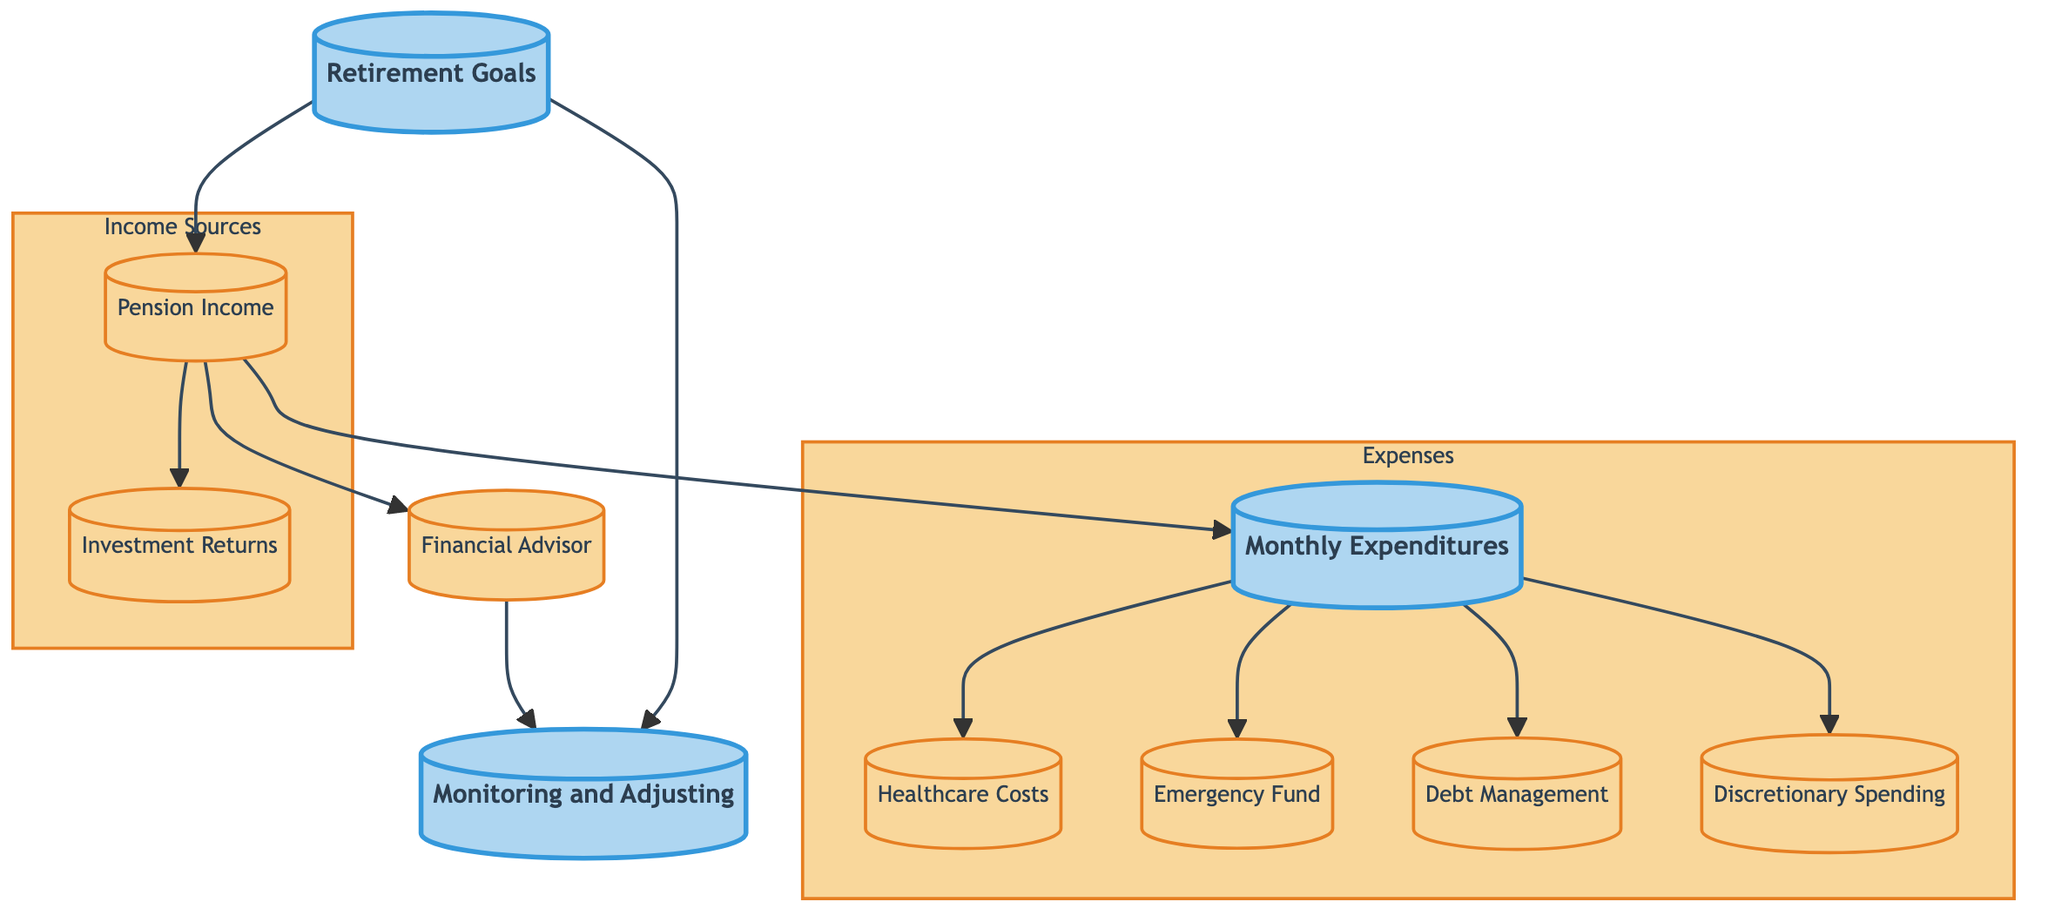What is the first step after defining retirement goals? The diagram indicates that after defining retirement goals, the next step is to calculate pension income, as shown by the arrow leading from "Retirement Goals" to "Pension Income."
Answer: calculate pension income How many key categories are presented in the flowchart? The flowchart categorizes the information into two main categories: Income Sources and Expenses. Therefore, the number of key categories is two.
Answer: two What follows pension income in the flowchart? Following the node for pension income, the diagram shows an arrow pointing to two subsequent nodes: investment returns and monthly expenditures.
Answer: investment returns and monthly expenditures Which two types of expenditures come after monthly expenditures? From the "Monthly Expenditures" node, there are three arrows directing to healthcare costs, emergency fund, and debt management. The question seeks two types, so choosing healthcare costs and emergency fund would suffice.
Answer: healthcare costs and emergency fund What should someone do to manage their debts according to the diagram? The diagram shows that after identifying monthly expenditures, individuals are directed to plan for debt management, as indicated by the arrow leading from "Monthly Expenditures" to "Debt Management."
Answer: plan to pay off debts What is indicated by the arrow connecting the financial advisor and monitoring and adjusting? The arrow connecting these two nodes illustrates that after consulting with a financial advisor, the individual should also continuously monitor and adjust their financial plan. This shows the relationship of ongoing action that stems from seeking professional advice.
Answer: continuously monitor and adjust What happens if retirement goals are not defined? While the flowchart does not explicitly state the consequences of not defining retirement goals, it can be inferred that without this first step, one may not effectively calculate pension income or plan subsequent financial management actions. Thus, the flow could not initiate properly.
Answer: ineffective financial planning How are discretionary spending and monthly expenditures related? The flowchart shows that discretionary spending stems from monthly expenditures, as evidenced by the connecting arrow. This signifies that budgeting for discretionary spending is a consideration within the broader context of managing monthly expenditures.
Answer: discretionary spending is derived from monthly expenditures 